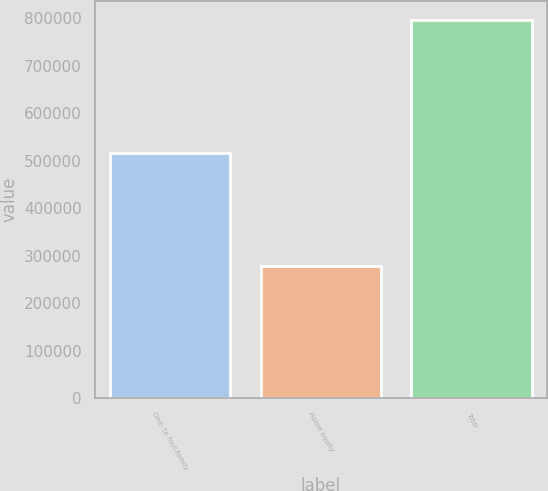Convert chart to OTSL. <chart><loc_0><loc_0><loc_500><loc_500><bar_chart><fcel>One- to four-family<fcel>Home equity<fcel>Total<nl><fcel>516314<fcel>279031<fcel>795345<nl></chart> 